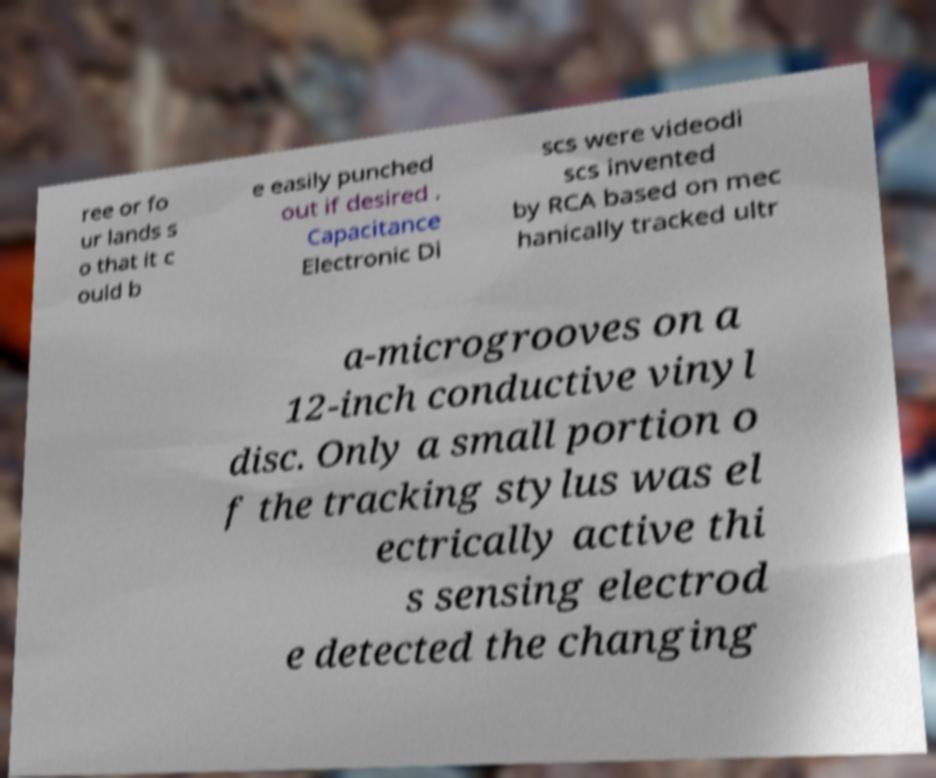Could you extract and type out the text from this image? ree or fo ur lands s o that it c ould b e easily punched out if desired . Capacitance Electronic Di scs were videodi scs invented by RCA based on mec hanically tracked ultr a-microgrooves on a 12-inch conductive vinyl disc. Only a small portion o f the tracking stylus was el ectrically active thi s sensing electrod e detected the changing 